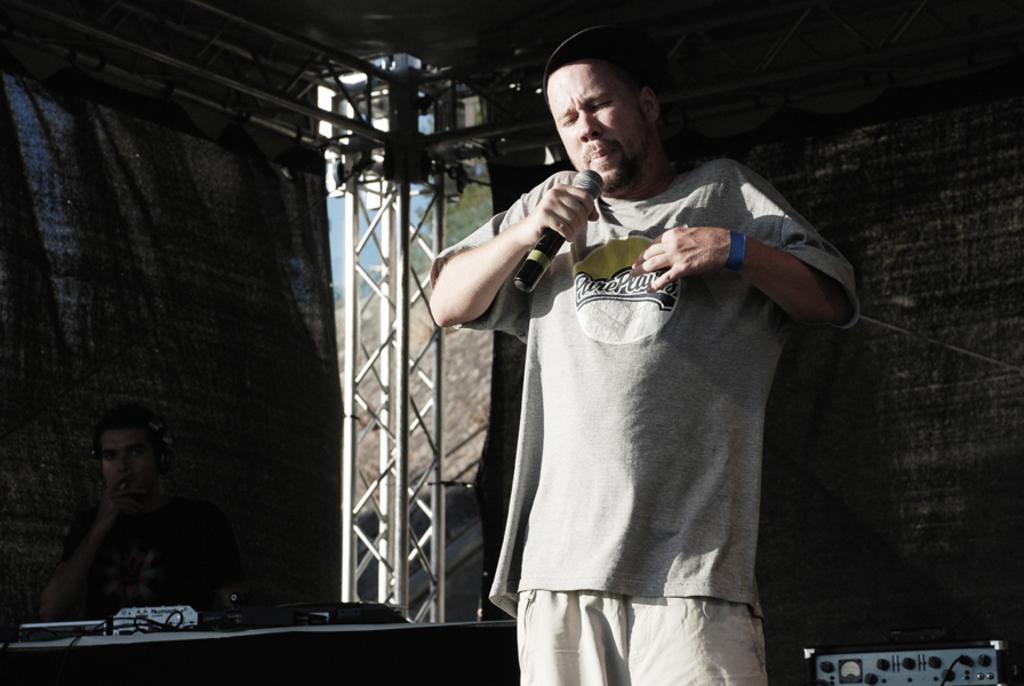In one or two sentences, can you explain what this image depicts? In this picture we can see e a person is standing and he is holding a microphone he sing a song beside one person is sitting and his just operating a sound system m we can see a black color clothes at the back side. 